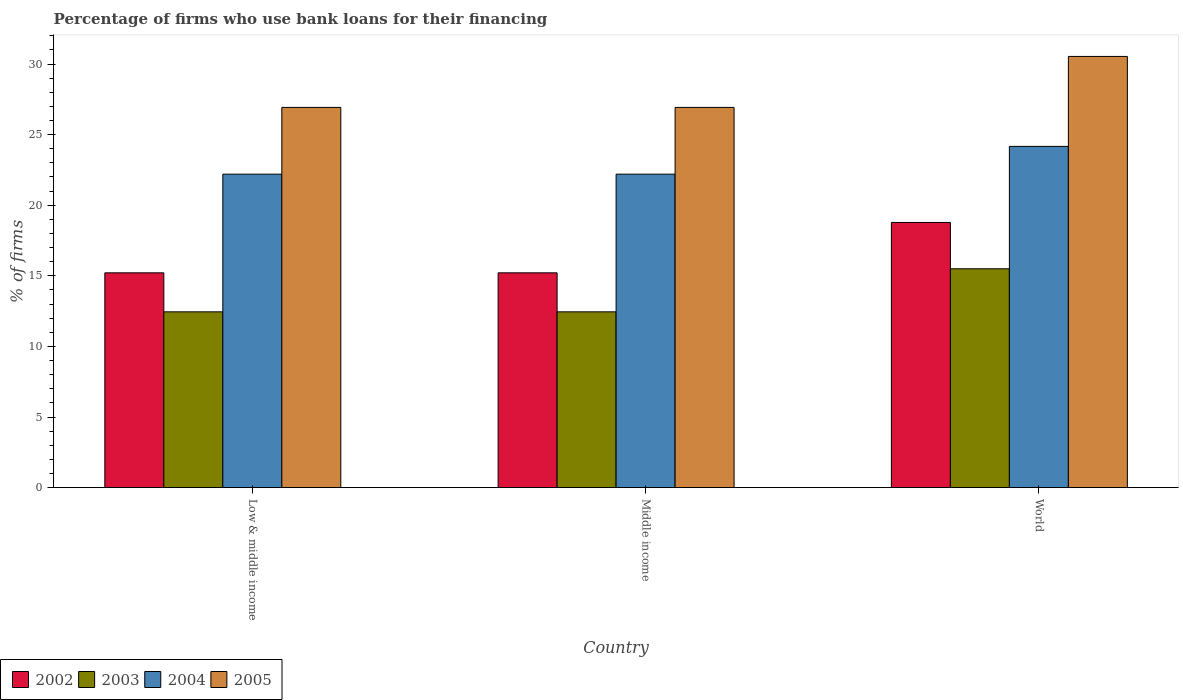How many different coloured bars are there?
Your answer should be very brief. 4. How many groups of bars are there?
Ensure brevity in your answer.  3. Are the number of bars per tick equal to the number of legend labels?
Your answer should be compact. Yes. How many bars are there on the 3rd tick from the left?
Give a very brief answer. 4. What is the percentage of firms who use bank loans for their financing in 2002 in World?
Keep it short and to the point. 18.78. In which country was the percentage of firms who use bank loans for their financing in 2002 maximum?
Offer a very short reply. World. What is the total percentage of firms who use bank loans for their financing in 2004 in the graph?
Offer a terse response. 68.57. What is the difference between the percentage of firms who use bank loans for their financing in 2002 in Middle income and that in World?
Make the answer very short. -3.57. What is the difference between the percentage of firms who use bank loans for their financing in 2005 in Low & middle income and the percentage of firms who use bank loans for their financing in 2003 in World?
Ensure brevity in your answer.  11.43. What is the average percentage of firms who use bank loans for their financing in 2004 per country?
Provide a succinct answer. 22.86. What is the difference between the percentage of firms who use bank loans for their financing of/in 2005 and percentage of firms who use bank loans for their financing of/in 2002 in Low & middle income?
Provide a short and direct response. 11.72. In how many countries, is the percentage of firms who use bank loans for their financing in 2003 greater than 7 %?
Provide a succinct answer. 3. What is the ratio of the percentage of firms who use bank loans for their financing in 2005 in Middle income to that in World?
Offer a very short reply. 0.88. Is the percentage of firms who use bank loans for their financing in 2002 in Middle income less than that in World?
Keep it short and to the point. Yes. Is the difference between the percentage of firms who use bank loans for their financing in 2005 in Middle income and World greater than the difference between the percentage of firms who use bank loans for their financing in 2002 in Middle income and World?
Give a very brief answer. No. What is the difference between the highest and the second highest percentage of firms who use bank loans for their financing in 2004?
Ensure brevity in your answer.  1.97. What is the difference between the highest and the lowest percentage of firms who use bank loans for their financing in 2003?
Keep it short and to the point. 3.05. Is the sum of the percentage of firms who use bank loans for their financing in 2005 in Low & middle income and World greater than the maximum percentage of firms who use bank loans for their financing in 2003 across all countries?
Keep it short and to the point. Yes. Is it the case that in every country, the sum of the percentage of firms who use bank loans for their financing in 2003 and percentage of firms who use bank loans for their financing in 2002 is greater than the sum of percentage of firms who use bank loans for their financing in 2004 and percentage of firms who use bank loans for their financing in 2005?
Offer a very short reply. No. How many bars are there?
Keep it short and to the point. 12. What is the difference between two consecutive major ticks on the Y-axis?
Your answer should be compact. 5. Are the values on the major ticks of Y-axis written in scientific E-notation?
Ensure brevity in your answer.  No. Does the graph contain grids?
Your response must be concise. No. Where does the legend appear in the graph?
Your answer should be very brief. Bottom left. How many legend labels are there?
Provide a short and direct response. 4. How are the legend labels stacked?
Ensure brevity in your answer.  Horizontal. What is the title of the graph?
Provide a short and direct response. Percentage of firms who use bank loans for their financing. Does "1972" appear as one of the legend labels in the graph?
Give a very brief answer. No. What is the label or title of the X-axis?
Offer a very short reply. Country. What is the label or title of the Y-axis?
Offer a terse response. % of firms. What is the % of firms of 2002 in Low & middle income?
Your response must be concise. 15.21. What is the % of firms in 2003 in Low & middle income?
Make the answer very short. 12.45. What is the % of firms in 2004 in Low & middle income?
Ensure brevity in your answer.  22.2. What is the % of firms in 2005 in Low & middle income?
Make the answer very short. 26.93. What is the % of firms in 2002 in Middle income?
Your answer should be compact. 15.21. What is the % of firms in 2003 in Middle income?
Keep it short and to the point. 12.45. What is the % of firms in 2004 in Middle income?
Provide a succinct answer. 22.2. What is the % of firms in 2005 in Middle income?
Offer a terse response. 26.93. What is the % of firms in 2002 in World?
Offer a very short reply. 18.78. What is the % of firms in 2004 in World?
Offer a terse response. 24.17. What is the % of firms in 2005 in World?
Provide a succinct answer. 30.54. Across all countries, what is the maximum % of firms of 2002?
Make the answer very short. 18.78. Across all countries, what is the maximum % of firms of 2004?
Provide a succinct answer. 24.17. Across all countries, what is the maximum % of firms in 2005?
Provide a short and direct response. 30.54. Across all countries, what is the minimum % of firms of 2002?
Provide a short and direct response. 15.21. Across all countries, what is the minimum % of firms of 2003?
Give a very brief answer. 12.45. Across all countries, what is the minimum % of firms of 2004?
Provide a short and direct response. 22.2. Across all countries, what is the minimum % of firms of 2005?
Offer a terse response. 26.93. What is the total % of firms in 2002 in the graph?
Ensure brevity in your answer.  49.21. What is the total % of firms of 2003 in the graph?
Give a very brief answer. 40.4. What is the total % of firms in 2004 in the graph?
Offer a very short reply. 68.57. What is the total % of firms in 2005 in the graph?
Ensure brevity in your answer.  84.39. What is the difference between the % of firms in 2005 in Low & middle income and that in Middle income?
Offer a terse response. 0. What is the difference between the % of firms of 2002 in Low & middle income and that in World?
Ensure brevity in your answer.  -3.57. What is the difference between the % of firms in 2003 in Low & middle income and that in World?
Ensure brevity in your answer.  -3.05. What is the difference between the % of firms in 2004 in Low & middle income and that in World?
Your response must be concise. -1.97. What is the difference between the % of firms of 2005 in Low & middle income and that in World?
Keep it short and to the point. -3.61. What is the difference between the % of firms of 2002 in Middle income and that in World?
Give a very brief answer. -3.57. What is the difference between the % of firms of 2003 in Middle income and that in World?
Ensure brevity in your answer.  -3.05. What is the difference between the % of firms in 2004 in Middle income and that in World?
Keep it short and to the point. -1.97. What is the difference between the % of firms in 2005 in Middle income and that in World?
Your answer should be very brief. -3.61. What is the difference between the % of firms in 2002 in Low & middle income and the % of firms in 2003 in Middle income?
Your answer should be compact. 2.76. What is the difference between the % of firms in 2002 in Low & middle income and the % of firms in 2004 in Middle income?
Offer a very short reply. -6.99. What is the difference between the % of firms of 2002 in Low & middle income and the % of firms of 2005 in Middle income?
Offer a very short reply. -11.72. What is the difference between the % of firms of 2003 in Low & middle income and the % of firms of 2004 in Middle income?
Offer a terse response. -9.75. What is the difference between the % of firms of 2003 in Low & middle income and the % of firms of 2005 in Middle income?
Your response must be concise. -14.48. What is the difference between the % of firms of 2004 in Low & middle income and the % of firms of 2005 in Middle income?
Your answer should be compact. -4.73. What is the difference between the % of firms of 2002 in Low & middle income and the % of firms of 2003 in World?
Make the answer very short. -0.29. What is the difference between the % of firms in 2002 in Low & middle income and the % of firms in 2004 in World?
Offer a very short reply. -8.95. What is the difference between the % of firms in 2002 in Low & middle income and the % of firms in 2005 in World?
Ensure brevity in your answer.  -15.33. What is the difference between the % of firms in 2003 in Low & middle income and the % of firms in 2004 in World?
Your response must be concise. -11.72. What is the difference between the % of firms in 2003 in Low & middle income and the % of firms in 2005 in World?
Make the answer very short. -18.09. What is the difference between the % of firms of 2004 in Low & middle income and the % of firms of 2005 in World?
Ensure brevity in your answer.  -8.34. What is the difference between the % of firms of 2002 in Middle income and the % of firms of 2003 in World?
Your answer should be compact. -0.29. What is the difference between the % of firms in 2002 in Middle income and the % of firms in 2004 in World?
Keep it short and to the point. -8.95. What is the difference between the % of firms of 2002 in Middle income and the % of firms of 2005 in World?
Make the answer very short. -15.33. What is the difference between the % of firms of 2003 in Middle income and the % of firms of 2004 in World?
Your answer should be compact. -11.72. What is the difference between the % of firms in 2003 in Middle income and the % of firms in 2005 in World?
Your answer should be compact. -18.09. What is the difference between the % of firms of 2004 in Middle income and the % of firms of 2005 in World?
Your answer should be compact. -8.34. What is the average % of firms of 2002 per country?
Give a very brief answer. 16.4. What is the average % of firms in 2003 per country?
Provide a succinct answer. 13.47. What is the average % of firms of 2004 per country?
Make the answer very short. 22.86. What is the average % of firms of 2005 per country?
Your response must be concise. 28.13. What is the difference between the % of firms of 2002 and % of firms of 2003 in Low & middle income?
Your response must be concise. 2.76. What is the difference between the % of firms of 2002 and % of firms of 2004 in Low & middle income?
Offer a very short reply. -6.99. What is the difference between the % of firms in 2002 and % of firms in 2005 in Low & middle income?
Your response must be concise. -11.72. What is the difference between the % of firms of 2003 and % of firms of 2004 in Low & middle income?
Your response must be concise. -9.75. What is the difference between the % of firms of 2003 and % of firms of 2005 in Low & middle income?
Offer a very short reply. -14.48. What is the difference between the % of firms in 2004 and % of firms in 2005 in Low & middle income?
Provide a short and direct response. -4.73. What is the difference between the % of firms in 2002 and % of firms in 2003 in Middle income?
Your answer should be compact. 2.76. What is the difference between the % of firms of 2002 and % of firms of 2004 in Middle income?
Your response must be concise. -6.99. What is the difference between the % of firms in 2002 and % of firms in 2005 in Middle income?
Your answer should be very brief. -11.72. What is the difference between the % of firms of 2003 and % of firms of 2004 in Middle income?
Provide a short and direct response. -9.75. What is the difference between the % of firms in 2003 and % of firms in 2005 in Middle income?
Keep it short and to the point. -14.48. What is the difference between the % of firms in 2004 and % of firms in 2005 in Middle income?
Provide a succinct answer. -4.73. What is the difference between the % of firms of 2002 and % of firms of 2003 in World?
Offer a very short reply. 3.28. What is the difference between the % of firms of 2002 and % of firms of 2004 in World?
Offer a terse response. -5.39. What is the difference between the % of firms in 2002 and % of firms in 2005 in World?
Your answer should be very brief. -11.76. What is the difference between the % of firms of 2003 and % of firms of 2004 in World?
Your response must be concise. -8.67. What is the difference between the % of firms in 2003 and % of firms in 2005 in World?
Make the answer very short. -15.04. What is the difference between the % of firms in 2004 and % of firms in 2005 in World?
Your answer should be very brief. -6.37. What is the ratio of the % of firms of 2003 in Low & middle income to that in Middle income?
Give a very brief answer. 1. What is the ratio of the % of firms of 2004 in Low & middle income to that in Middle income?
Give a very brief answer. 1. What is the ratio of the % of firms in 2005 in Low & middle income to that in Middle income?
Provide a succinct answer. 1. What is the ratio of the % of firms of 2002 in Low & middle income to that in World?
Your response must be concise. 0.81. What is the ratio of the % of firms in 2003 in Low & middle income to that in World?
Give a very brief answer. 0.8. What is the ratio of the % of firms of 2004 in Low & middle income to that in World?
Keep it short and to the point. 0.92. What is the ratio of the % of firms of 2005 in Low & middle income to that in World?
Keep it short and to the point. 0.88. What is the ratio of the % of firms of 2002 in Middle income to that in World?
Keep it short and to the point. 0.81. What is the ratio of the % of firms of 2003 in Middle income to that in World?
Make the answer very short. 0.8. What is the ratio of the % of firms of 2004 in Middle income to that in World?
Your answer should be very brief. 0.92. What is the ratio of the % of firms of 2005 in Middle income to that in World?
Keep it short and to the point. 0.88. What is the difference between the highest and the second highest % of firms in 2002?
Provide a succinct answer. 3.57. What is the difference between the highest and the second highest % of firms of 2003?
Keep it short and to the point. 3.05. What is the difference between the highest and the second highest % of firms in 2004?
Provide a short and direct response. 1.97. What is the difference between the highest and the second highest % of firms of 2005?
Provide a short and direct response. 3.61. What is the difference between the highest and the lowest % of firms of 2002?
Offer a terse response. 3.57. What is the difference between the highest and the lowest % of firms of 2003?
Your response must be concise. 3.05. What is the difference between the highest and the lowest % of firms of 2004?
Offer a very short reply. 1.97. What is the difference between the highest and the lowest % of firms of 2005?
Provide a succinct answer. 3.61. 